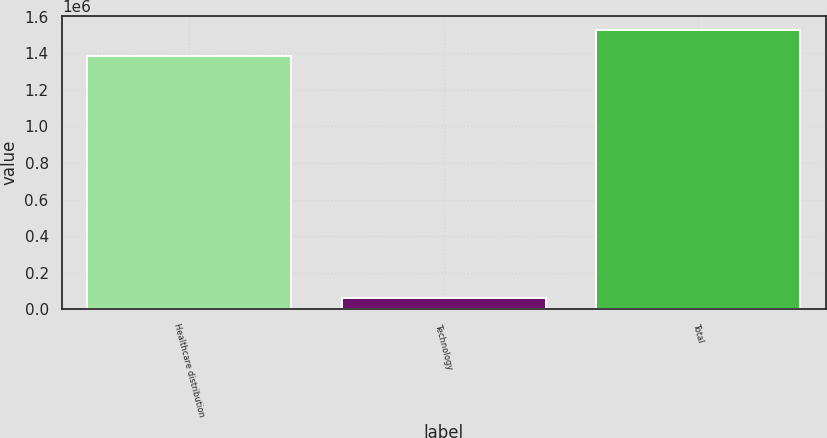<chart> <loc_0><loc_0><loc_500><loc_500><bar_chart><fcel>Healthcare distribution<fcel>Technology<fcel>Total<nl><fcel>1.38758e+06<fcel>62134<fcel>1.52634e+06<nl></chart> 